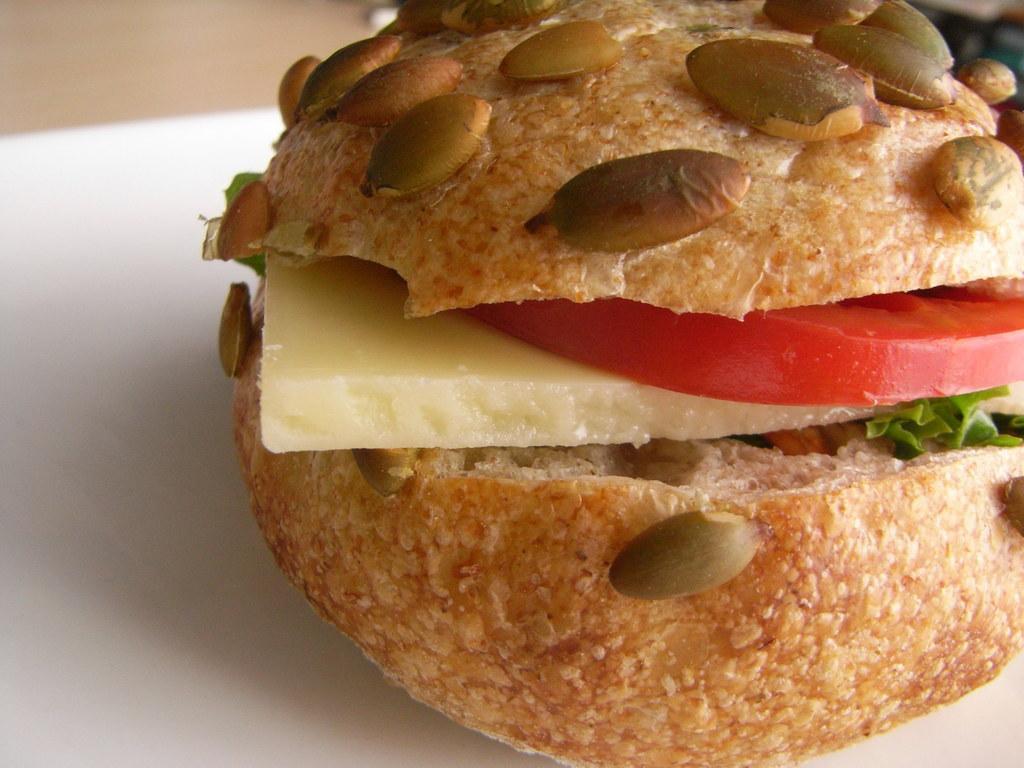Describe this image in one or two sentences. This picture shows a sandwich with some veggies on the table. 